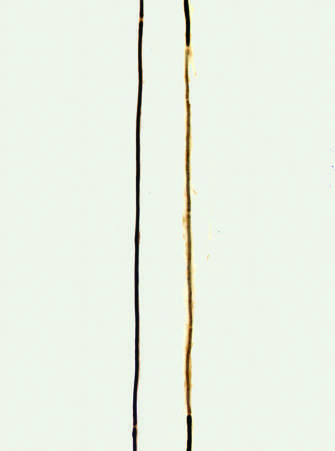s a normal axon with a long thick dark myelin internode flanked by nodes of ranvier?
Answer the question using a single word or phrase. Yes 